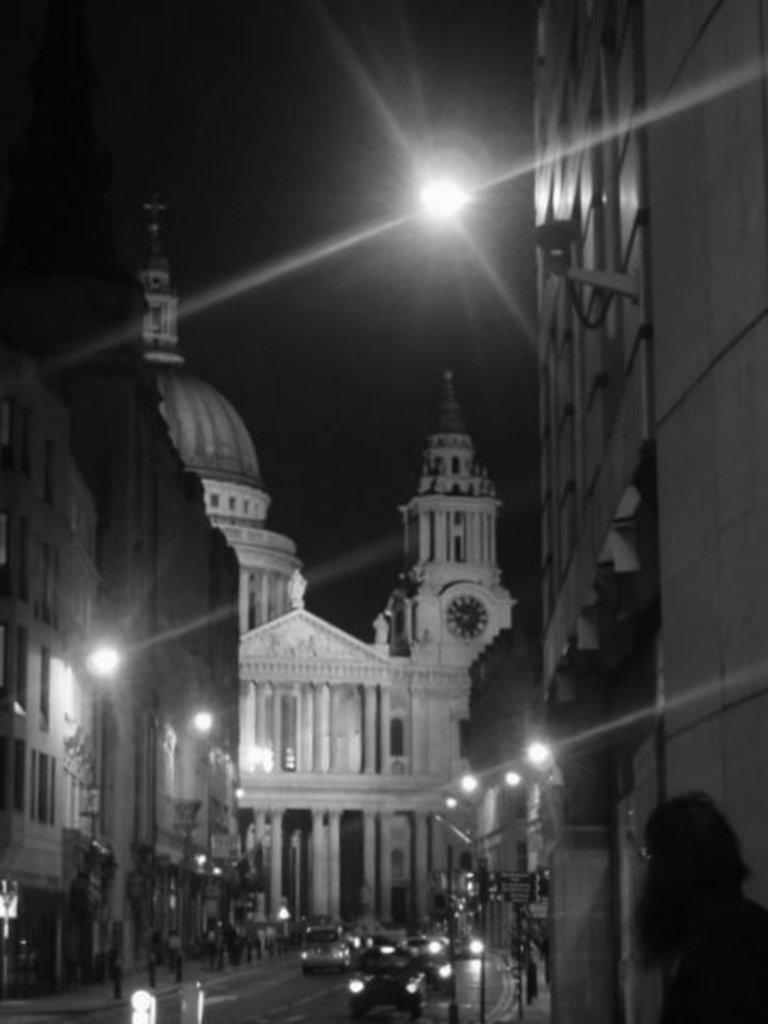In one or two sentences, can you explain what this image depicts? In this image I can see few buildings and on these buildings I can see number of lights. In the centre of this image I can see a road and on it I can see few vehicles. I can also see this image is black and white in colour. 